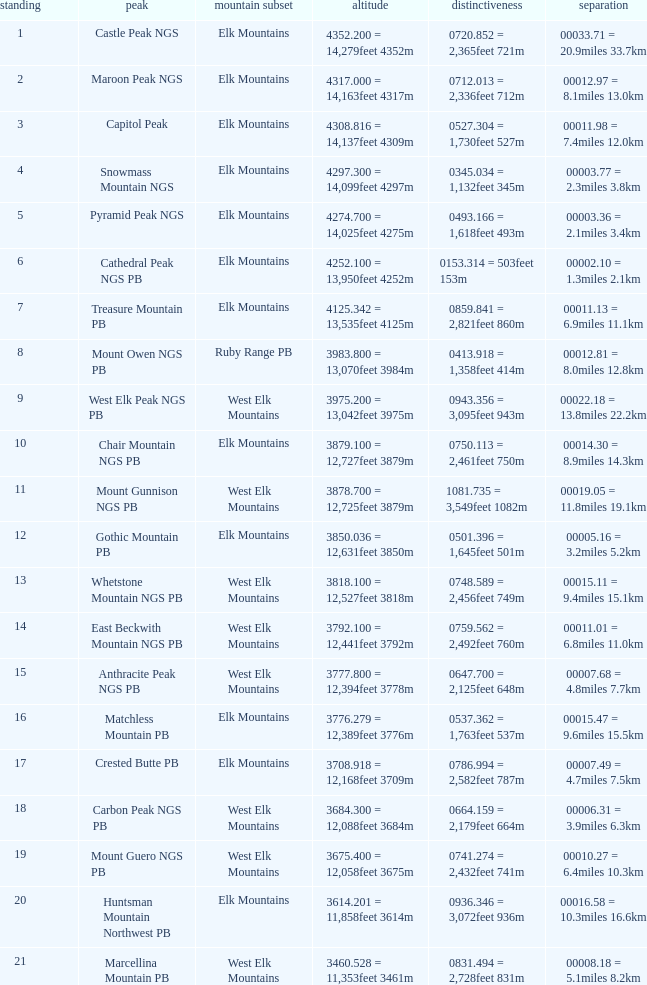Name the Prominence of the Mountain Peak of matchless mountain pb? 0537.362 = 1,763feet 537m. 